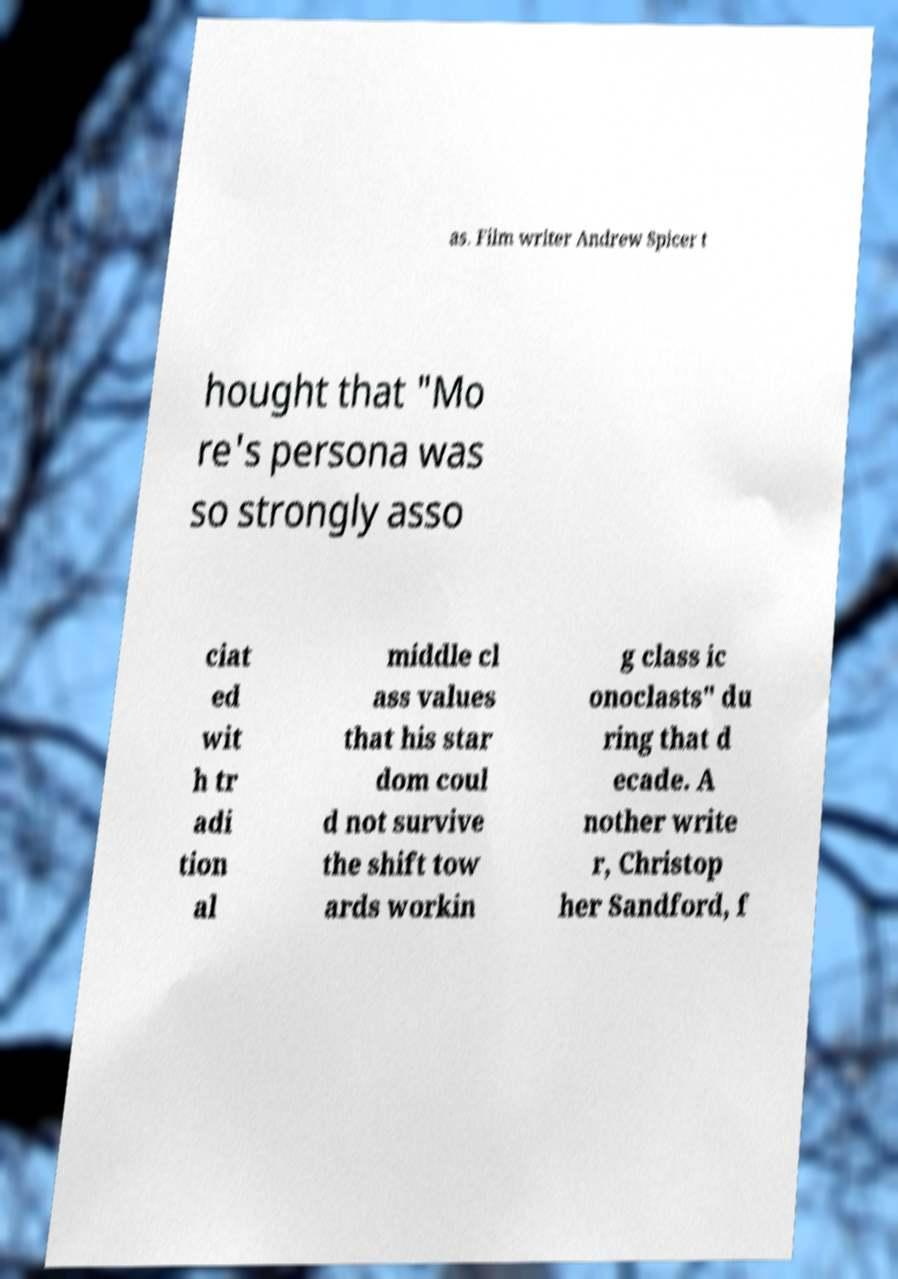Could you assist in decoding the text presented in this image and type it out clearly? as. Film writer Andrew Spicer t hought that "Mo re's persona was so strongly asso ciat ed wit h tr adi tion al middle cl ass values that his star dom coul d not survive the shift tow ards workin g class ic onoclasts" du ring that d ecade. A nother write r, Christop her Sandford, f 